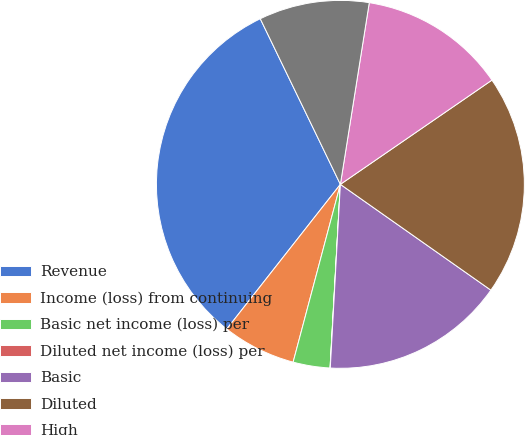Convert chart to OTSL. <chart><loc_0><loc_0><loc_500><loc_500><pie_chart><fcel>Revenue<fcel>Income (loss) from continuing<fcel>Basic net income (loss) per<fcel>Diluted net income (loss) per<fcel>Basic<fcel>Diluted<fcel>High<fcel>Low<nl><fcel>32.23%<fcel>6.46%<fcel>3.24%<fcel>0.02%<fcel>16.12%<fcel>19.34%<fcel>12.9%<fcel>9.68%<nl></chart> 